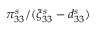Convert formula to latex. <formula><loc_0><loc_0><loc_500><loc_500>\pi _ { 3 3 } ^ { s } / ( \xi _ { 3 3 } ^ { s } - d _ { 3 3 } ^ { s } )</formula> 